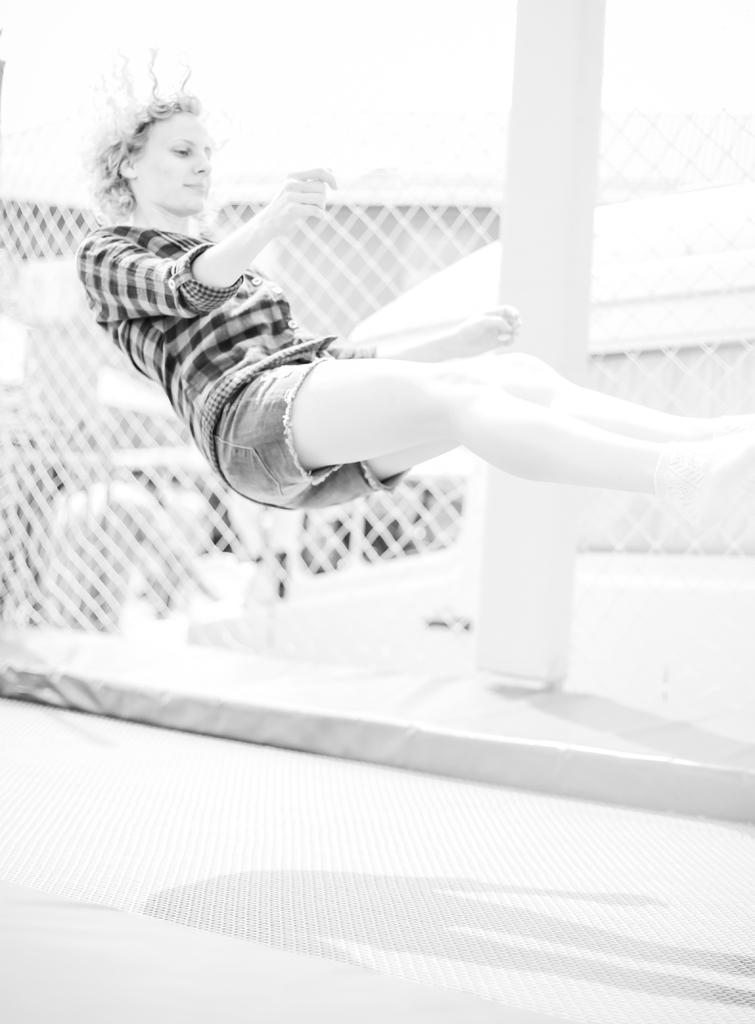Who or what is the main subject in the center of the image? There is a person in the center of the image. What can be seen in the background of the image? There is a pole and a net visible in the background of the image. What is at the bottom of the image? There is a road at the bottom of the image. How many pizzas are being served in the prison in the image? There is no mention of pizzas or a prison in the image; it features a person, a pole, a net, and a road. 